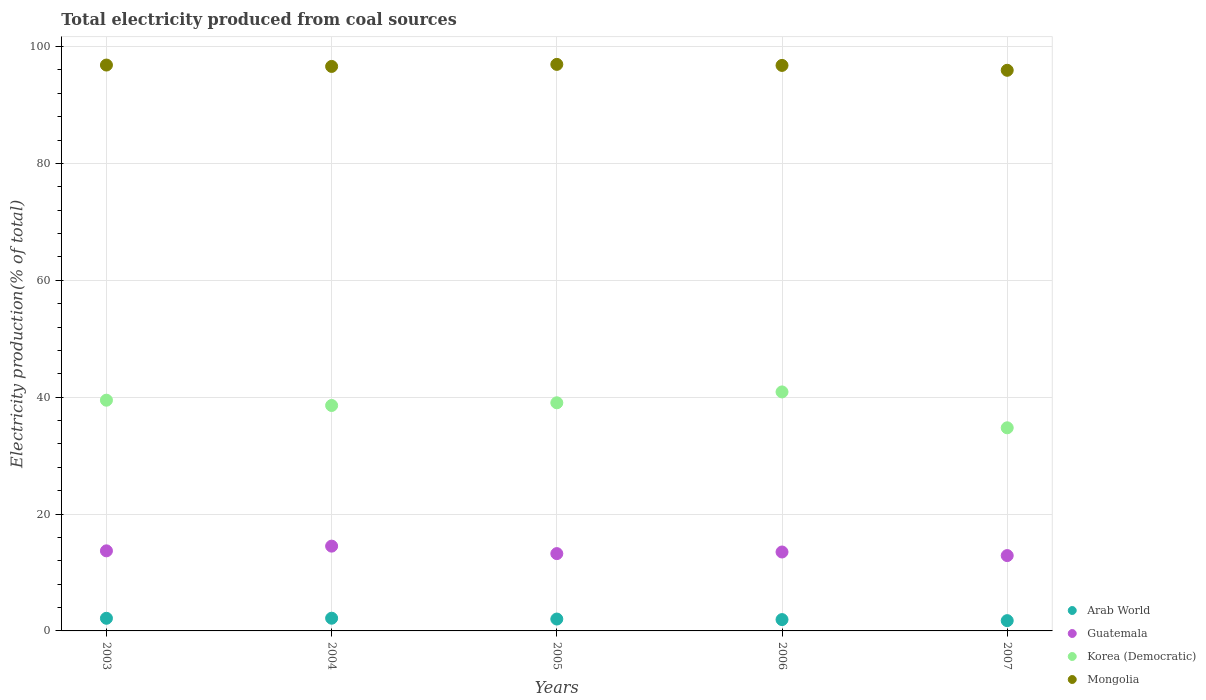What is the total electricity produced in Arab World in 2006?
Make the answer very short. 1.94. Across all years, what is the maximum total electricity produced in Mongolia?
Make the answer very short. 96.96. Across all years, what is the minimum total electricity produced in Mongolia?
Your answer should be compact. 95.95. In which year was the total electricity produced in Arab World maximum?
Provide a succinct answer. 2004. What is the total total electricity produced in Guatemala in the graph?
Give a very brief answer. 67.85. What is the difference between the total electricity produced in Arab World in 2004 and that in 2007?
Your answer should be very brief. 0.41. What is the difference between the total electricity produced in Korea (Democratic) in 2004 and the total electricity produced in Guatemala in 2005?
Your response must be concise. 25.35. What is the average total electricity produced in Arab World per year?
Provide a short and direct response. 2.01. In the year 2005, what is the difference between the total electricity produced in Guatemala and total electricity produced in Mongolia?
Offer a very short reply. -83.73. In how many years, is the total electricity produced in Mongolia greater than 52 %?
Your answer should be very brief. 5. What is the ratio of the total electricity produced in Korea (Democratic) in 2004 to that in 2007?
Your answer should be very brief. 1.11. Is the difference between the total electricity produced in Guatemala in 2004 and 2005 greater than the difference between the total electricity produced in Mongolia in 2004 and 2005?
Provide a succinct answer. Yes. What is the difference between the highest and the second highest total electricity produced in Guatemala?
Provide a succinct answer. 0.81. What is the difference between the highest and the lowest total electricity produced in Arab World?
Provide a short and direct response. 0.41. Is it the case that in every year, the sum of the total electricity produced in Korea (Democratic) and total electricity produced in Guatemala  is greater than the sum of total electricity produced in Mongolia and total electricity produced in Arab World?
Offer a terse response. No. Does the total electricity produced in Korea (Democratic) monotonically increase over the years?
Make the answer very short. No. How many dotlines are there?
Keep it short and to the point. 4. Does the graph contain grids?
Provide a succinct answer. Yes. How many legend labels are there?
Your answer should be very brief. 4. How are the legend labels stacked?
Your answer should be very brief. Vertical. What is the title of the graph?
Your response must be concise. Total electricity produced from coal sources. Does "Nepal" appear as one of the legend labels in the graph?
Your response must be concise. No. What is the label or title of the X-axis?
Keep it short and to the point. Years. What is the label or title of the Y-axis?
Provide a short and direct response. Electricity production(% of total). What is the Electricity production(% of total) of Arab World in 2003?
Keep it short and to the point. 2.16. What is the Electricity production(% of total) of Guatemala in 2003?
Your answer should be very brief. 13.71. What is the Electricity production(% of total) in Korea (Democratic) in 2003?
Your answer should be very brief. 39.49. What is the Electricity production(% of total) of Mongolia in 2003?
Give a very brief answer. 96.85. What is the Electricity production(% of total) of Arab World in 2004?
Provide a succinct answer. 2.17. What is the Electricity production(% of total) in Guatemala in 2004?
Ensure brevity in your answer.  14.51. What is the Electricity production(% of total) of Korea (Democratic) in 2004?
Offer a very short reply. 38.58. What is the Electricity production(% of total) in Mongolia in 2004?
Make the answer very short. 96.61. What is the Electricity production(% of total) of Arab World in 2005?
Provide a short and direct response. 2.03. What is the Electricity production(% of total) of Guatemala in 2005?
Your response must be concise. 13.23. What is the Electricity production(% of total) of Korea (Democratic) in 2005?
Provide a short and direct response. 39.04. What is the Electricity production(% of total) of Mongolia in 2005?
Keep it short and to the point. 96.96. What is the Electricity production(% of total) of Arab World in 2006?
Your answer should be very brief. 1.94. What is the Electricity production(% of total) in Guatemala in 2006?
Ensure brevity in your answer.  13.51. What is the Electricity production(% of total) of Korea (Democratic) in 2006?
Your answer should be very brief. 40.9. What is the Electricity production(% of total) in Mongolia in 2006?
Make the answer very short. 96.78. What is the Electricity production(% of total) in Arab World in 2007?
Your answer should be compact. 1.76. What is the Electricity production(% of total) in Guatemala in 2007?
Your answer should be compact. 12.89. What is the Electricity production(% of total) in Korea (Democratic) in 2007?
Ensure brevity in your answer.  34.76. What is the Electricity production(% of total) in Mongolia in 2007?
Ensure brevity in your answer.  95.95. Across all years, what is the maximum Electricity production(% of total) of Arab World?
Your answer should be very brief. 2.17. Across all years, what is the maximum Electricity production(% of total) of Guatemala?
Offer a very short reply. 14.51. Across all years, what is the maximum Electricity production(% of total) in Korea (Democratic)?
Your answer should be very brief. 40.9. Across all years, what is the maximum Electricity production(% of total) of Mongolia?
Your response must be concise. 96.96. Across all years, what is the minimum Electricity production(% of total) in Arab World?
Provide a short and direct response. 1.76. Across all years, what is the minimum Electricity production(% of total) in Guatemala?
Ensure brevity in your answer.  12.89. Across all years, what is the minimum Electricity production(% of total) of Korea (Democratic)?
Provide a succinct answer. 34.76. Across all years, what is the minimum Electricity production(% of total) of Mongolia?
Your response must be concise. 95.95. What is the total Electricity production(% of total) in Arab World in the graph?
Offer a very short reply. 10.07. What is the total Electricity production(% of total) of Guatemala in the graph?
Keep it short and to the point. 67.85. What is the total Electricity production(% of total) of Korea (Democratic) in the graph?
Keep it short and to the point. 192.78. What is the total Electricity production(% of total) in Mongolia in the graph?
Your answer should be very brief. 483.14. What is the difference between the Electricity production(% of total) of Arab World in 2003 and that in 2004?
Make the answer very short. -0.01. What is the difference between the Electricity production(% of total) of Guatemala in 2003 and that in 2004?
Offer a very short reply. -0.81. What is the difference between the Electricity production(% of total) in Korea (Democratic) in 2003 and that in 2004?
Offer a terse response. 0.91. What is the difference between the Electricity production(% of total) in Mongolia in 2003 and that in 2004?
Provide a short and direct response. 0.24. What is the difference between the Electricity production(% of total) of Arab World in 2003 and that in 2005?
Provide a short and direct response. 0.13. What is the difference between the Electricity production(% of total) of Guatemala in 2003 and that in 2005?
Keep it short and to the point. 0.47. What is the difference between the Electricity production(% of total) in Korea (Democratic) in 2003 and that in 2005?
Keep it short and to the point. 0.44. What is the difference between the Electricity production(% of total) of Mongolia in 2003 and that in 2005?
Your answer should be compact. -0.11. What is the difference between the Electricity production(% of total) of Arab World in 2003 and that in 2006?
Offer a very short reply. 0.23. What is the difference between the Electricity production(% of total) in Guatemala in 2003 and that in 2006?
Keep it short and to the point. 0.2. What is the difference between the Electricity production(% of total) of Korea (Democratic) in 2003 and that in 2006?
Make the answer very short. -1.42. What is the difference between the Electricity production(% of total) in Mongolia in 2003 and that in 2006?
Ensure brevity in your answer.  0.06. What is the difference between the Electricity production(% of total) of Arab World in 2003 and that in 2007?
Keep it short and to the point. 0.4. What is the difference between the Electricity production(% of total) of Guatemala in 2003 and that in 2007?
Provide a succinct answer. 0.81. What is the difference between the Electricity production(% of total) in Korea (Democratic) in 2003 and that in 2007?
Your answer should be very brief. 4.72. What is the difference between the Electricity production(% of total) in Mongolia in 2003 and that in 2007?
Provide a short and direct response. 0.9. What is the difference between the Electricity production(% of total) of Arab World in 2004 and that in 2005?
Ensure brevity in your answer.  0.14. What is the difference between the Electricity production(% of total) in Guatemala in 2004 and that in 2005?
Offer a very short reply. 1.28. What is the difference between the Electricity production(% of total) in Korea (Democratic) in 2004 and that in 2005?
Offer a terse response. -0.46. What is the difference between the Electricity production(% of total) of Mongolia in 2004 and that in 2005?
Provide a short and direct response. -0.35. What is the difference between the Electricity production(% of total) in Arab World in 2004 and that in 2006?
Offer a very short reply. 0.24. What is the difference between the Electricity production(% of total) of Korea (Democratic) in 2004 and that in 2006?
Your answer should be compact. -2.32. What is the difference between the Electricity production(% of total) in Mongolia in 2004 and that in 2006?
Make the answer very short. -0.17. What is the difference between the Electricity production(% of total) in Arab World in 2004 and that in 2007?
Your answer should be compact. 0.41. What is the difference between the Electricity production(% of total) of Guatemala in 2004 and that in 2007?
Keep it short and to the point. 1.62. What is the difference between the Electricity production(% of total) in Korea (Democratic) in 2004 and that in 2007?
Make the answer very short. 3.82. What is the difference between the Electricity production(% of total) of Mongolia in 2004 and that in 2007?
Your answer should be very brief. 0.66. What is the difference between the Electricity production(% of total) of Arab World in 2005 and that in 2006?
Keep it short and to the point. 0.1. What is the difference between the Electricity production(% of total) of Guatemala in 2005 and that in 2006?
Give a very brief answer. -0.28. What is the difference between the Electricity production(% of total) of Korea (Democratic) in 2005 and that in 2006?
Your answer should be compact. -1.86. What is the difference between the Electricity production(% of total) of Mongolia in 2005 and that in 2006?
Keep it short and to the point. 0.17. What is the difference between the Electricity production(% of total) in Arab World in 2005 and that in 2007?
Give a very brief answer. 0.27. What is the difference between the Electricity production(% of total) in Guatemala in 2005 and that in 2007?
Provide a short and direct response. 0.34. What is the difference between the Electricity production(% of total) in Korea (Democratic) in 2005 and that in 2007?
Ensure brevity in your answer.  4.28. What is the difference between the Electricity production(% of total) in Mongolia in 2005 and that in 2007?
Ensure brevity in your answer.  1.01. What is the difference between the Electricity production(% of total) in Arab World in 2006 and that in 2007?
Ensure brevity in your answer.  0.18. What is the difference between the Electricity production(% of total) of Guatemala in 2006 and that in 2007?
Your answer should be very brief. 0.61. What is the difference between the Electricity production(% of total) in Korea (Democratic) in 2006 and that in 2007?
Provide a short and direct response. 6.14. What is the difference between the Electricity production(% of total) in Mongolia in 2006 and that in 2007?
Your answer should be very brief. 0.84. What is the difference between the Electricity production(% of total) in Arab World in 2003 and the Electricity production(% of total) in Guatemala in 2004?
Offer a very short reply. -12.35. What is the difference between the Electricity production(% of total) of Arab World in 2003 and the Electricity production(% of total) of Korea (Democratic) in 2004?
Provide a short and direct response. -36.42. What is the difference between the Electricity production(% of total) in Arab World in 2003 and the Electricity production(% of total) in Mongolia in 2004?
Keep it short and to the point. -94.45. What is the difference between the Electricity production(% of total) of Guatemala in 2003 and the Electricity production(% of total) of Korea (Democratic) in 2004?
Give a very brief answer. -24.88. What is the difference between the Electricity production(% of total) of Guatemala in 2003 and the Electricity production(% of total) of Mongolia in 2004?
Your answer should be very brief. -82.9. What is the difference between the Electricity production(% of total) of Korea (Democratic) in 2003 and the Electricity production(% of total) of Mongolia in 2004?
Ensure brevity in your answer.  -57.12. What is the difference between the Electricity production(% of total) of Arab World in 2003 and the Electricity production(% of total) of Guatemala in 2005?
Ensure brevity in your answer.  -11.07. What is the difference between the Electricity production(% of total) in Arab World in 2003 and the Electricity production(% of total) in Korea (Democratic) in 2005?
Offer a very short reply. -36.88. What is the difference between the Electricity production(% of total) in Arab World in 2003 and the Electricity production(% of total) in Mongolia in 2005?
Provide a short and direct response. -94.8. What is the difference between the Electricity production(% of total) in Guatemala in 2003 and the Electricity production(% of total) in Korea (Democratic) in 2005?
Your answer should be very brief. -25.34. What is the difference between the Electricity production(% of total) in Guatemala in 2003 and the Electricity production(% of total) in Mongolia in 2005?
Your answer should be very brief. -83.25. What is the difference between the Electricity production(% of total) of Korea (Democratic) in 2003 and the Electricity production(% of total) of Mongolia in 2005?
Provide a short and direct response. -57.47. What is the difference between the Electricity production(% of total) in Arab World in 2003 and the Electricity production(% of total) in Guatemala in 2006?
Your response must be concise. -11.34. What is the difference between the Electricity production(% of total) of Arab World in 2003 and the Electricity production(% of total) of Korea (Democratic) in 2006?
Your answer should be very brief. -38.74. What is the difference between the Electricity production(% of total) of Arab World in 2003 and the Electricity production(% of total) of Mongolia in 2006?
Offer a very short reply. -94.62. What is the difference between the Electricity production(% of total) of Guatemala in 2003 and the Electricity production(% of total) of Korea (Democratic) in 2006?
Your response must be concise. -27.2. What is the difference between the Electricity production(% of total) of Guatemala in 2003 and the Electricity production(% of total) of Mongolia in 2006?
Your response must be concise. -83.08. What is the difference between the Electricity production(% of total) in Korea (Democratic) in 2003 and the Electricity production(% of total) in Mongolia in 2006?
Provide a short and direct response. -57.3. What is the difference between the Electricity production(% of total) in Arab World in 2003 and the Electricity production(% of total) in Guatemala in 2007?
Give a very brief answer. -10.73. What is the difference between the Electricity production(% of total) of Arab World in 2003 and the Electricity production(% of total) of Korea (Democratic) in 2007?
Your response must be concise. -32.6. What is the difference between the Electricity production(% of total) of Arab World in 2003 and the Electricity production(% of total) of Mongolia in 2007?
Your answer should be very brief. -93.78. What is the difference between the Electricity production(% of total) in Guatemala in 2003 and the Electricity production(% of total) in Korea (Democratic) in 2007?
Give a very brief answer. -21.06. What is the difference between the Electricity production(% of total) in Guatemala in 2003 and the Electricity production(% of total) in Mongolia in 2007?
Offer a very short reply. -82.24. What is the difference between the Electricity production(% of total) in Korea (Democratic) in 2003 and the Electricity production(% of total) in Mongolia in 2007?
Your response must be concise. -56.46. What is the difference between the Electricity production(% of total) of Arab World in 2004 and the Electricity production(% of total) of Guatemala in 2005?
Offer a terse response. -11.06. What is the difference between the Electricity production(% of total) in Arab World in 2004 and the Electricity production(% of total) in Korea (Democratic) in 2005?
Make the answer very short. -36.87. What is the difference between the Electricity production(% of total) of Arab World in 2004 and the Electricity production(% of total) of Mongolia in 2005?
Give a very brief answer. -94.78. What is the difference between the Electricity production(% of total) in Guatemala in 2004 and the Electricity production(% of total) in Korea (Democratic) in 2005?
Your answer should be very brief. -24.53. What is the difference between the Electricity production(% of total) in Guatemala in 2004 and the Electricity production(% of total) in Mongolia in 2005?
Provide a succinct answer. -82.45. What is the difference between the Electricity production(% of total) of Korea (Democratic) in 2004 and the Electricity production(% of total) of Mongolia in 2005?
Keep it short and to the point. -58.38. What is the difference between the Electricity production(% of total) of Arab World in 2004 and the Electricity production(% of total) of Guatemala in 2006?
Provide a short and direct response. -11.33. What is the difference between the Electricity production(% of total) of Arab World in 2004 and the Electricity production(% of total) of Korea (Democratic) in 2006?
Keep it short and to the point. -38.73. What is the difference between the Electricity production(% of total) of Arab World in 2004 and the Electricity production(% of total) of Mongolia in 2006?
Your answer should be compact. -94.61. What is the difference between the Electricity production(% of total) in Guatemala in 2004 and the Electricity production(% of total) in Korea (Democratic) in 2006?
Make the answer very short. -26.39. What is the difference between the Electricity production(% of total) of Guatemala in 2004 and the Electricity production(% of total) of Mongolia in 2006?
Offer a very short reply. -82.27. What is the difference between the Electricity production(% of total) of Korea (Democratic) in 2004 and the Electricity production(% of total) of Mongolia in 2006?
Your response must be concise. -58.2. What is the difference between the Electricity production(% of total) in Arab World in 2004 and the Electricity production(% of total) in Guatemala in 2007?
Ensure brevity in your answer.  -10.72. What is the difference between the Electricity production(% of total) in Arab World in 2004 and the Electricity production(% of total) in Korea (Democratic) in 2007?
Your response must be concise. -32.59. What is the difference between the Electricity production(% of total) of Arab World in 2004 and the Electricity production(% of total) of Mongolia in 2007?
Provide a succinct answer. -93.77. What is the difference between the Electricity production(% of total) in Guatemala in 2004 and the Electricity production(% of total) in Korea (Democratic) in 2007?
Your answer should be very brief. -20.25. What is the difference between the Electricity production(% of total) of Guatemala in 2004 and the Electricity production(% of total) of Mongolia in 2007?
Your answer should be compact. -81.44. What is the difference between the Electricity production(% of total) in Korea (Democratic) in 2004 and the Electricity production(% of total) in Mongolia in 2007?
Provide a succinct answer. -57.37. What is the difference between the Electricity production(% of total) of Arab World in 2005 and the Electricity production(% of total) of Guatemala in 2006?
Provide a short and direct response. -11.47. What is the difference between the Electricity production(% of total) of Arab World in 2005 and the Electricity production(% of total) of Korea (Democratic) in 2006?
Ensure brevity in your answer.  -38.87. What is the difference between the Electricity production(% of total) of Arab World in 2005 and the Electricity production(% of total) of Mongolia in 2006?
Provide a succinct answer. -94.75. What is the difference between the Electricity production(% of total) of Guatemala in 2005 and the Electricity production(% of total) of Korea (Democratic) in 2006?
Your answer should be very brief. -27.67. What is the difference between the Electricity production(% of total) in Guatemala in 2005 and the Electricity production(% of total) in Mongolia in 2006?
Provide a short and direct response. -83.55. What is the difference between the Electricity production(% of total) of Korea (Democratic) in 2005 and the Electricity production(% of total) of Mongolia in 2006?
Offer a very short reply. -57.74. What is the difference between the Electricity production(% of total) in Arab World in 2005 and the Electricity production(% of total) in Guatemala in 2007?
Offer a very short reply. -10.86. What is the difference between the Electricity production(% of total) of Arab World in 2005 and the Electricity production(% of total) of Korea (Democratic) in 2007?
Offer a very short reply. -32.73. What is the difference between the Electricity production(% of total) in Arab World in 2005 and the Electricity production(% of total) in Mongolia in 2007?
Make the answer very short. -93.91. What is the difference between the Electricity production(% of total) of Guatemala in 2005 and the Electricity production(% of total) of Korea (Democratic) in 2007?
Give a very brief answer. -21.53. What is the difference between the Electricity production(% of total) in Guatemala in 2005 and the Electricity production(% of total) in Mongolia in 2007?
Your answer should be very brief. -82.72. What is the difference between the Electricity production(% of total) of Korea (Democratic) in 2005 and the Electricity production(% of total) of Mongolia in 2007?
Your answer should be very brief. -56.9. What is the difference between the Electricity production(% of total) of Arab World in 2006 and the Electricity production(% of total) of Guatemala in 2007?
Ensure brevity in your answer.  -10.96. What is the difference between the Electricity production(% of total) in Arab World in 2006 and the Electricity production(% of total) in Korea (Democratic) in 2007?
Your answer should be compact. -32.82. What is the difference between the Electricity production(% of total) in Arab World in 2006 and the Electricity production(% of total) in Mongolia in 2007?
Your answer should be compact. -94.01. What is the difference between the Electricity production(% of total) of Guatemala in 2006 and the Electricity production(% of total) of Korea (Democratic) in 2007?
Give a very brief answer. -21.26. What is the difference between the Electricity production(% of total) in Guatemala in 2006 and the Electricity production(% of total) in Mongolia in 2007?
Ensure brevity in your answer.  -82.44. What is the difference between the Electricity production(% of total) of Korea (Democratic) in 2006 and the Electricity production(% of total) of Mongolia in 2007?
Give a very brief answer. -55.04. What is the average Electricity production(% of total) in Arab World per year?
Make the answer very short. 2.01. What is the average Electricity production(% of total) in Guatemala per year?
Make the answer very short. 13.57. What is the average Electricity production(% of total) in Korea (Democratic) per year?
Ensure brevity in your answer.  38.56. What is the average Electricity production(% of total) in Mongolia per year?
Provide a succinct answer. 96.63. In the year 2003, what is the difference between the Electricity production(% of total) of Arab World and Electricity production(% of total) of Guatemala?
Give a very brief answer. -11.54. In the year 2003, what is the difference between the Electricity production(% of total) in Arab World and Electricity production(% of total) in Korea (Democratic)?
Ensure brevity in your answer.  -37.32. In the year 2003, what is the difference between the Electricity production(% of total) of Arab World and Electricity production(% of total) of Mongolia?
Keep it short and to the point. -94.68. In the year 2003, what is the difference between the Electricity production(% of total) in Guatemala and Electricity production(% of total) in Korea (Democratic)?
Your answer should be compact. -25.78. In the year 2003, what is the difference between the Electricity production(% of total) in Guatemala and Electricity production(% of total) in Mongolia?
Your answer should be compact. -83.14. In the year 2003, what is the difference between the Electricity production(% of total) in Korea (Democratic) and Electricity production(% of total) in Mongolia?
Offer a very short reply. -57.36. In the year 2004, what is the difference between the Electricity production(% of total) in Arab World and Electricity production(% of total) in Guatemala?
Offer a terse response. -12.34. In the year 2004, what is the difference between the Electricity production(% of total) of Arab World and Electricity production(% of total) of Korea (Democratic)?
Give a very brief answer. -36.41. In the year 2004, what is the difference between the Electricity production(% of total) of Arab World and Electricity production(% of total) of Mongolia?
Offer a very short reply. -94.44. In the year 2004, what is the difference between the Electricity production(% of total) in Guatemala and Electricity production(% of total) in Korea (Democratic)?
Provide a short and direct response. -24.07. In the year 2004, what is the difference between the Electricity production(% of total) in Guatemala and Electricity production(% of total) in Mongolia?
Provide a short and direct response. -82.1. In the year 2004, what is the difference between the Electricity production(% of total) in Korea (Democratic) and Electricity production(% of total) in Mongolia?
Ensure brevity in your answer.  -58.03. In the year 2005, what is the difference between the Electricity production(% of total) of Arab World and Electricity production(% of total) of Guatemala?
Make the answer very short. -11.2. In the year 2005, what is the difference between the Electricity production(% of total) of Arab World and Electricity production(% of total) of Korea (Democratic)?
Keep it short and to the point. -37.01. In the year 2005, what is the difference between the Electricity production(% of total) in Arab World and Electricity production(% of total) in Mongolia?
Offer a very short reply. -94.92. In the year 2005, what is the difference between the Electricity production(% of total) in Guatemala and Electricity production(% of total) in Korea (Democratic)?
Provide a succinct answer. -25.81. In the year 2005, what is the difference between the Electricity production(% of total) in Guatemala and Electricity production(% of total) in Mongolia?
Keep it short and to the point. -83.73. In the year 2005, what is the difference between the Electricity production(% of total) of Korea (Democratic) and Electricity production(% of total) of Mongolia?
Provide a short and direct response. -57.91. In the year 2006, what is the difference between the Electricity production(% of total) in Arab World and Electricity production(% of total) in Guatemala?
Your answer should be very brief. -11.57. In the year 2006, what is the difference between the Electricity production(% of total) of Arab World and Electricity production(% of total) of Korea (Democratic)?
Offer a very short reply. -38.97. In the year 2006, what is the difference between the Electricity production(% of total) in Arab World and Electricity production(% of total) in Mongolia?
Keep it short and to the point. -94.85. In the year 2006, what is the difference between the Electricity production(% of total) of Guatemala and Electricity production(% of total) of Korea (Democratic)?
Offer a very short reply. -27.4. In the year 2006, what is the difference between the Electricity production(% of total) in Guatemala and Electricity production(% of total) in Mongolia?
Make the answer very short. -83.28. In the year 2006, what is the difference between the Electricity production(% of total) in Korea (Democratic) and Electricity production(% of total) in Mongolia?
Give a very brief answer. -55.88. In the year 2007, what is the difference between the Electricity production(% of total) in Arab World and Electricity production(% of total) in Guatemala?
Make the answer very short. -11.13. In the year 2007, what is the difference between the Electricity production(% of total) in Arab World and Electricity production(% of total) in Korea (Democratic)?
Your answer should be very brief. -33. In the year 2007, what is the difference between the Electricity production(% of total) in Arab World and Electricity production(% of total) in Mongolia?
Give a very brief answer. -94.19. In the year 2007, what is the difference between the Electricity production(% of total) in Guatemala and Electricity production(% of total) in Korea (Democratic)?
Ensure brevity in your answer.  -21.87. In the year 2007, what is the difference between the Electricity production(% of total) in Guatemala and Electricity production(% of total) in Mongolia?
Your answer should be compact. -83.05. In the year 2007, what is the difference between the Electricity production(% of total) in Korea (Democratic) and Electricity production(% of total) in Mongolia?
Your answer should be very brief. -61.18. What is the ratio of the Electricity production(% of total) of Arab World in 2003 to that in 2004?
Ensure brevity in your answer.  0.99. What is the ratio of the Electricity production(% of total) of Guatemala in 2003 to that in 2004?
Give a very brief answer. 0.94. What is the ratio of the Electricity production(% of total) in Korea (Democratic) in 2003 to that in 2004?
Your answer should be very brief. 1.02. What is the ratio of the Electricity production(% of total) in Mongolia in 2003 to that in 2004?
Make the answer very short. 1. What is the ratio of the Electricity production(% of total) in Arab World in 2003 to that in 2005?
Provide a short and direct response. 1.06. What is the ratio of the Electricity production(% of total) in Guatemala in 2003 to that in 2005?
Your answer should be compact. 1.04. What is the ratio of the Electricity production(% of total) in Korea (Democratic) in 2003 to that in 2005?
Give a very brief answer. 1.01. What is the ratio of the Electricity production(% of total) of Arab World in 2003 to that in 2006?
Your response must be concise. 1.12. What is the ratio of the Electricity production(% of total) of Guatemala in 2003 to that in 2006?
Provide a short and direct response. 1.01. What is the ratio of the Electricity production(% of total) of Korea (Democratic) in 2003 to that in 2006?
Keep it short and to the point. 0.97. What is the ratio of the Electricity production(% of total) of Arab World in 2003 to that in 2007?
Give a very brief answer. 1.23. What is the ratio of the Electricity production(% of total) of Guatemala in 2003 to that in 2007?
Offer a very short reply. 1.06. What is the ratio of the Electricity production(% of total) of Korea (Democratic) in 2003 to that in 2007?
Your answer should be very brief. 1.14. What is the ratio of the Electricity production(% of total) of Mongolia in 2003 to that in 2007?
Provide a short and direct response. 1.01. What is the ratio of the Electricity production(% of total) in Arab World in 2004 to that in 2005?
Provide a short and direct response. 1.07. What is the ratio of the Electricity production(% of total) in Guatemala in 2004 to that in 2005?
Your response must be concise. 1.1. What is the ratio of the Electricity production(% of total) of Arab World in 2004 to that in 2006?
Your response must be concise. 1.12. What is the ratio of the Electricity production(% of total) of Guatemala in 2004 to that in 2006?
Your answer should be compact. 1.07. What is the ratio of the Electricity production(% of total) in Korea (Democratic) in 2004 to that in 2006?
Offer a very short reply. 0.94. What is the ratio of the Electricity production(% of total) in Arab World in 2004 to that in 2007?
Ensure brevity in your answer.  1.24. What is the ratio of the Electricity production(% of total) in Guatemala in 2004 to that in 2007?
Provide a succinct answer. 1.13. What is the ratio of the Electricity production(% of total) in Korea (Democratic) in 2004 to that in 2007?
Provide a short and direct response. 1.11. What is the ratio of the Electricity production(% of total) of Arab World in 2005 to that in 2006?
Provide a short and direct response. 1.05. What is the ratio of the Electricity production(% of total) in Guatemala in 2005 to that in 2006?
Your response must be concise. 0.98. What is the ratio of the Electricity production(% of total) in Korea (Democratic) in 2005 to that in 2006?
Make the answer very short. 0.95. What is the ratio of the Electricity production(% of total) of Mongolia in 2005 to that in 2006?
Give a very brief answer. 1. What is the ratio of the Electricity production(% of total) in Arab World in 2005 to that in 2007?
Offer a terse response. 1.16. What is the ratio of the Electricity production(% of total) of Guatemala in 2005 to that in 2007?
Ensure brevity in your answer.  1.03. What is the ratio of the Electricity production(% of total) in Korea (Democratic) in 2005 to that in 2007?
Your response must be concise. 1.12. What is the ratio of the Electricity production(% of total) of Mongolia in 2005 to that in 2007?
Offer a terse response. 1.01. What is the ratio of the Electricity production(% of total) in Arab World in 2006 to that in 2007?
Your answer should be very brief. 1.1. What is the ratio of the Electricity production(% of total) of Guatemala in 2006 to that in 2007?
Provide a succinct answer. 1.05. What is the ratio of the Electricity production(% of total) of Korea (Democratic) in 2006 to that in 2007?
Ensure brevity in your answer.  1.18. What is the ratio of the Electricity production(% of total) in Mongolia in 2006 to that in 2007?
Your response must be concise. 1.01. What is the difference between the highest and the second highest Electricity production(% of total) of Arab World?
Your answer should be very brief. 0.01. What is the difference between the highest and the second highest Electricity production(% of total) in Guatemala?
Make the answer very short. 0.81. What is the difference between the highest and the second highest Electricity production(% of total) in Korea (Democratic)?
Ensure brevity in your answer.  1.42. What is the difference between the highest and the second highest Electricity production(% of total) of Mongolia?
Offer a terse response. 0.11. What is the difference between the highest and the lowest Electricity production(% of total) in Arab World?
Keep it short and to the point. 0.41. What is the difference between the highest and the lowest Electricity production(% of total) of Guatemala?
Your answer should be compact. 1.62. What is the difference between the highest and the lowest Electricity production(% of total) of Korea (Democratic)?
Your answer should be compact. 6.14. What is the difference between the highest and the lowest Electricity production(% of total) in Mongolia?
Your answer should be compact. 1.01. 